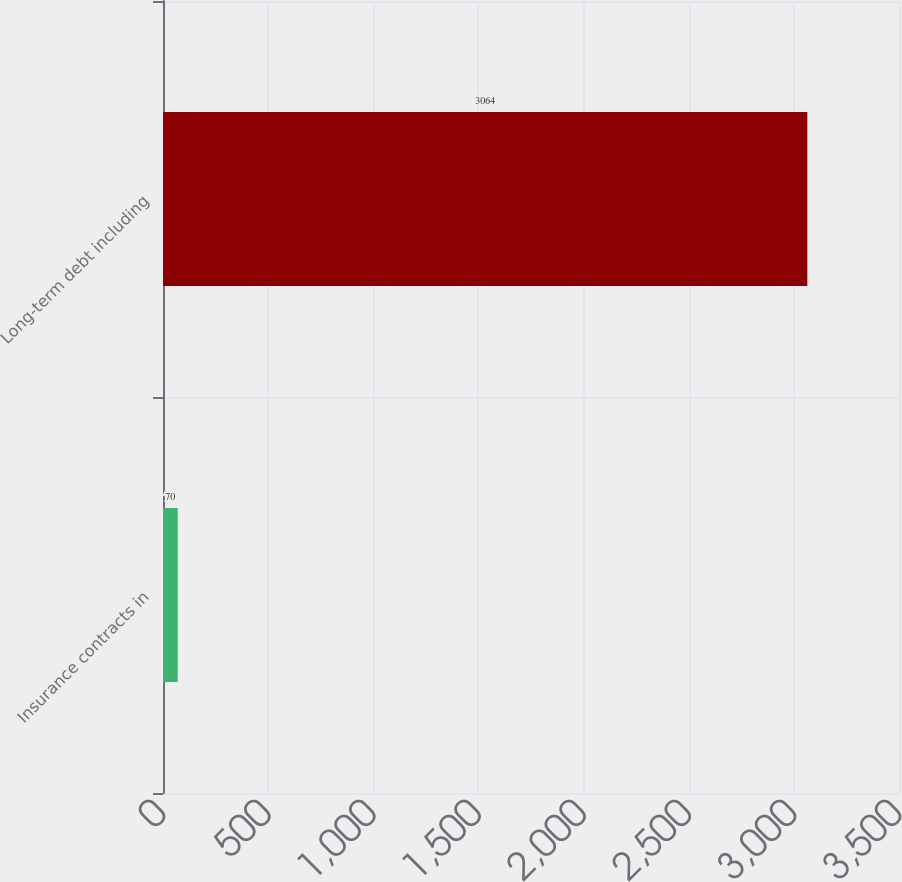Convert chart to OTSL. <chart><loc_0><loc_0><loc_500><loc_500><bar_chart><fcel>Insurance contracts in<fcel>Long-term debt including<nl><fcel>70<fcel>3064<nl></chart> 